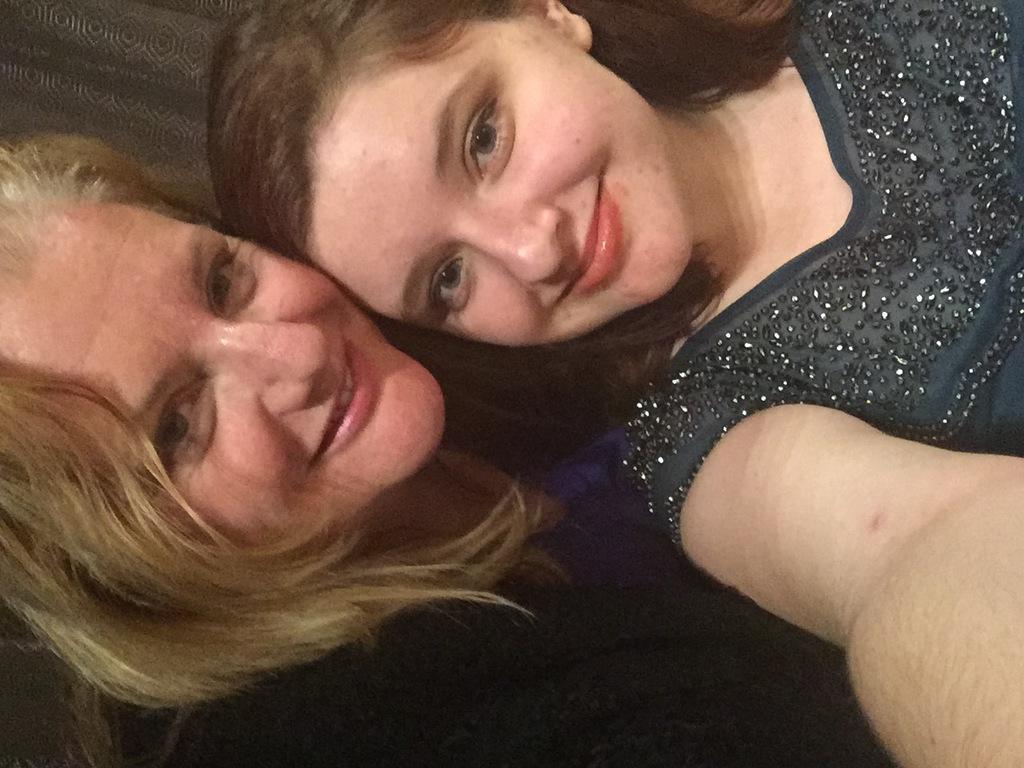Can you describe this image briefly? In the picture I can see two women. These two women are smiling. 